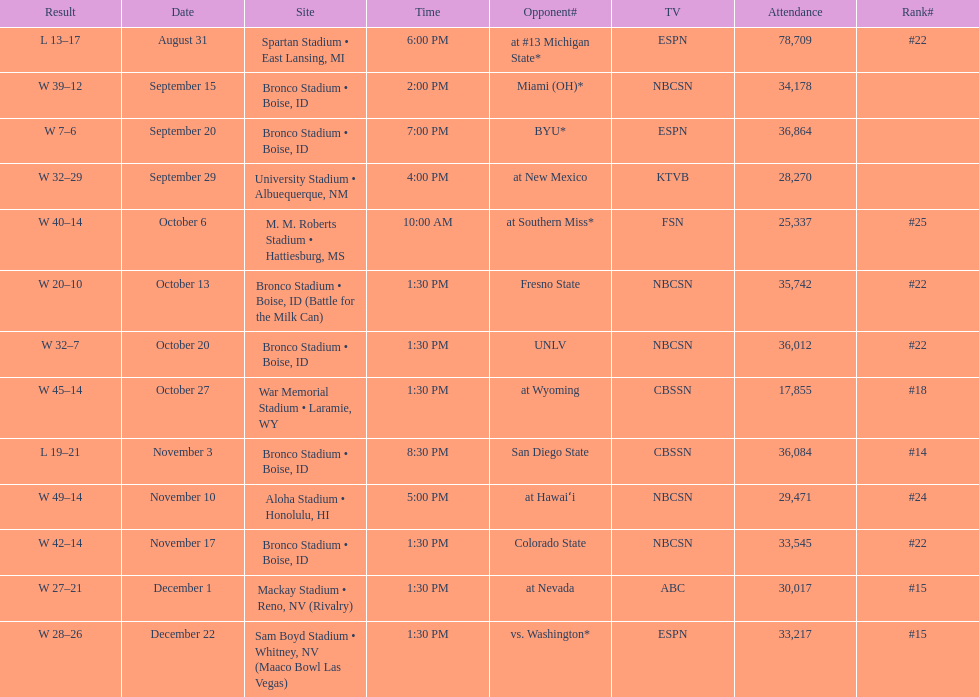What was there top ranked position of the season? #14. 